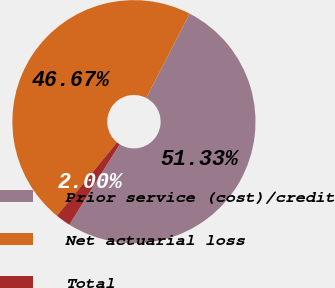Convert chart to OTSL. <chart><loc_0><loc_0><loc_500><loc_500><pie_chart><fcel>Prior service (cost)/credit<fcel>Net actuarial loss<fcel>Total<nl><fcel>51.33%<fcel>46.67%<fcel>2.0%<nl></chart> 